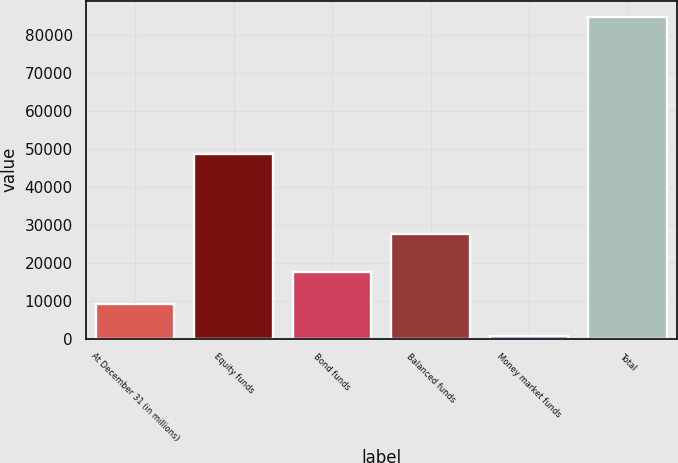<chart> <loc_0><loc_0><loc_500><loc_500><bar_chart><fcel>At December 31 (in millions)<fcel>Equity funds<fcel>Bond funds<fcel>Balanced funds<fcel>Money market funds<fcel>Total<nl><fcel>9134.3<fcel>48594<fcel>17538.6<fcel>27656<fcel>730<fcel>84773<nl></chart> 